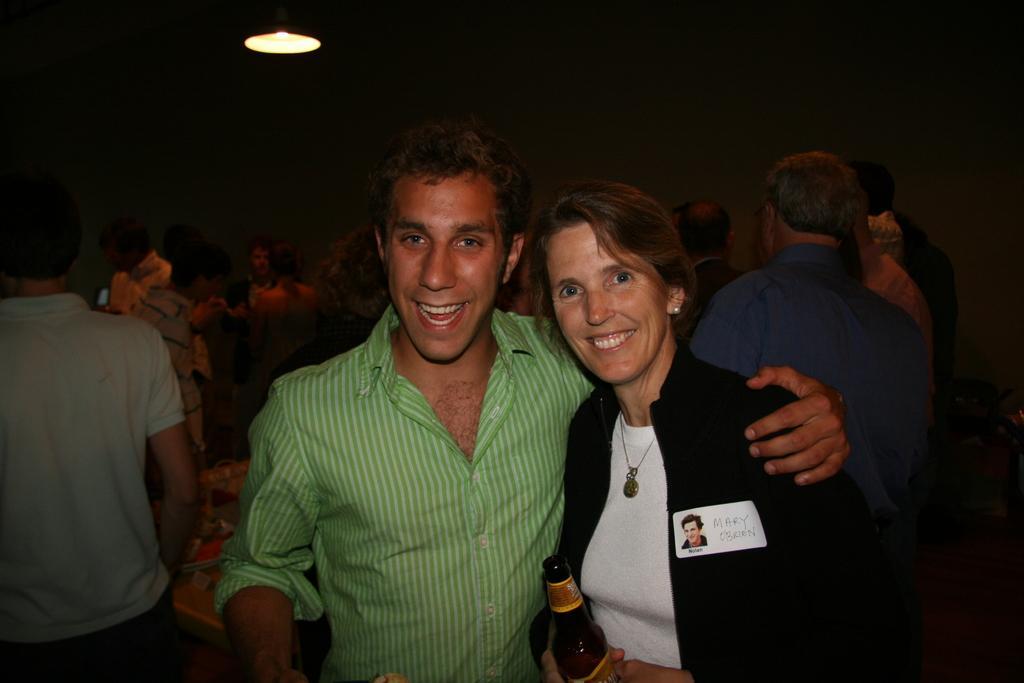How would you summarize this image in a sentence or two? It is taken in a closed room there are number of people standing and in the center of the picture there is a woman wearing a black coat and holding a bottle, beside her there is one person wearing green shirt and behind him there is a table present. 